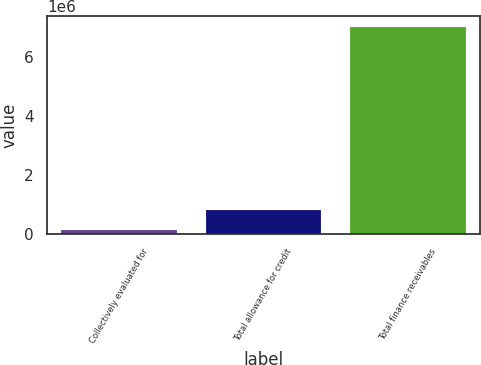Convert chart to OTSL. <chart><loc_0><loc_0><loc_500><loc_500><bar_chart><fcel>Collectively evaluated for<fcel>Total allowance for credit<fcel>Total finance receivables<nl><fcel>147178<fcel>833993<fcel>7.01533e+06<nl></chart> 